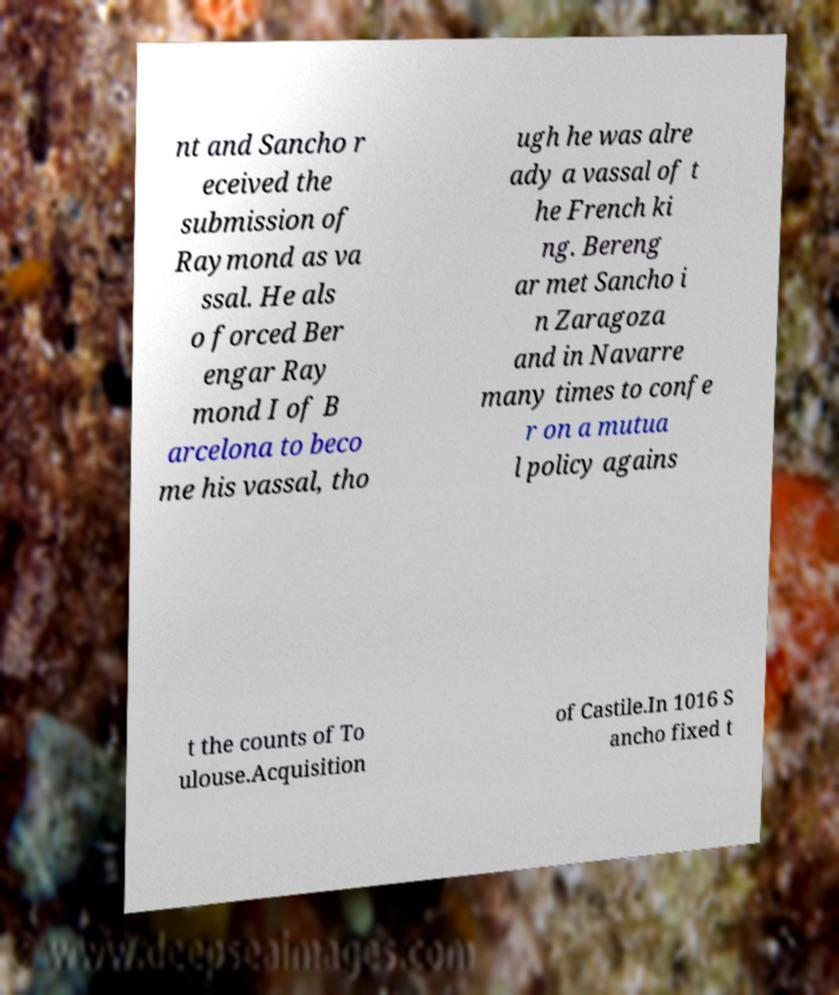Can you accurately transcribe the text from the provided image for me? nt and Sancho r eceived the submission of Raymond as va ssal. He als o forced Ber engar Ray mond I of B arcelona to beco me his vassal, tho ugh he was alre ady a vassal of t he French ki ng. Bereng ar met Sancho i n Zaragoza and in Navarre many times to confe r on a mutua l policy agains t the counts of To ulouse.Acquisition of Castile.In 1016 S ancho fixed t 